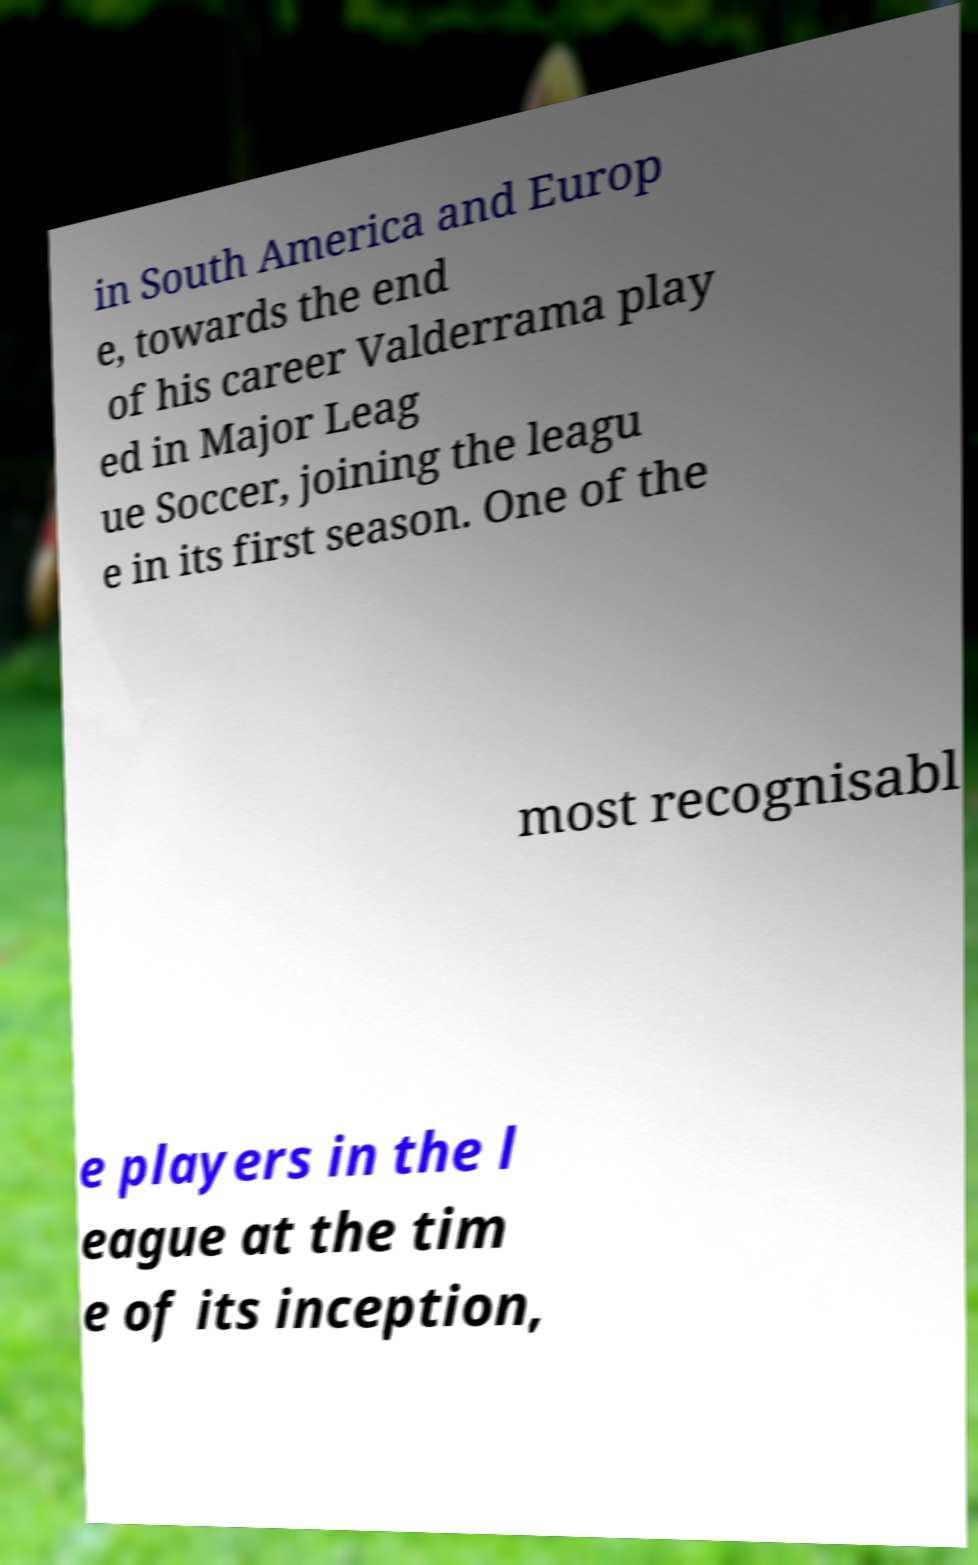I need the written content from this picture converted into text. Can you do that? in South America and Europ e, towards the end of his career Valderrama play ed in Major Leag ue Soccer, joining the leagu e in its first season. One of the most recognisabl e players in the l eague at the tim e of its inception, 